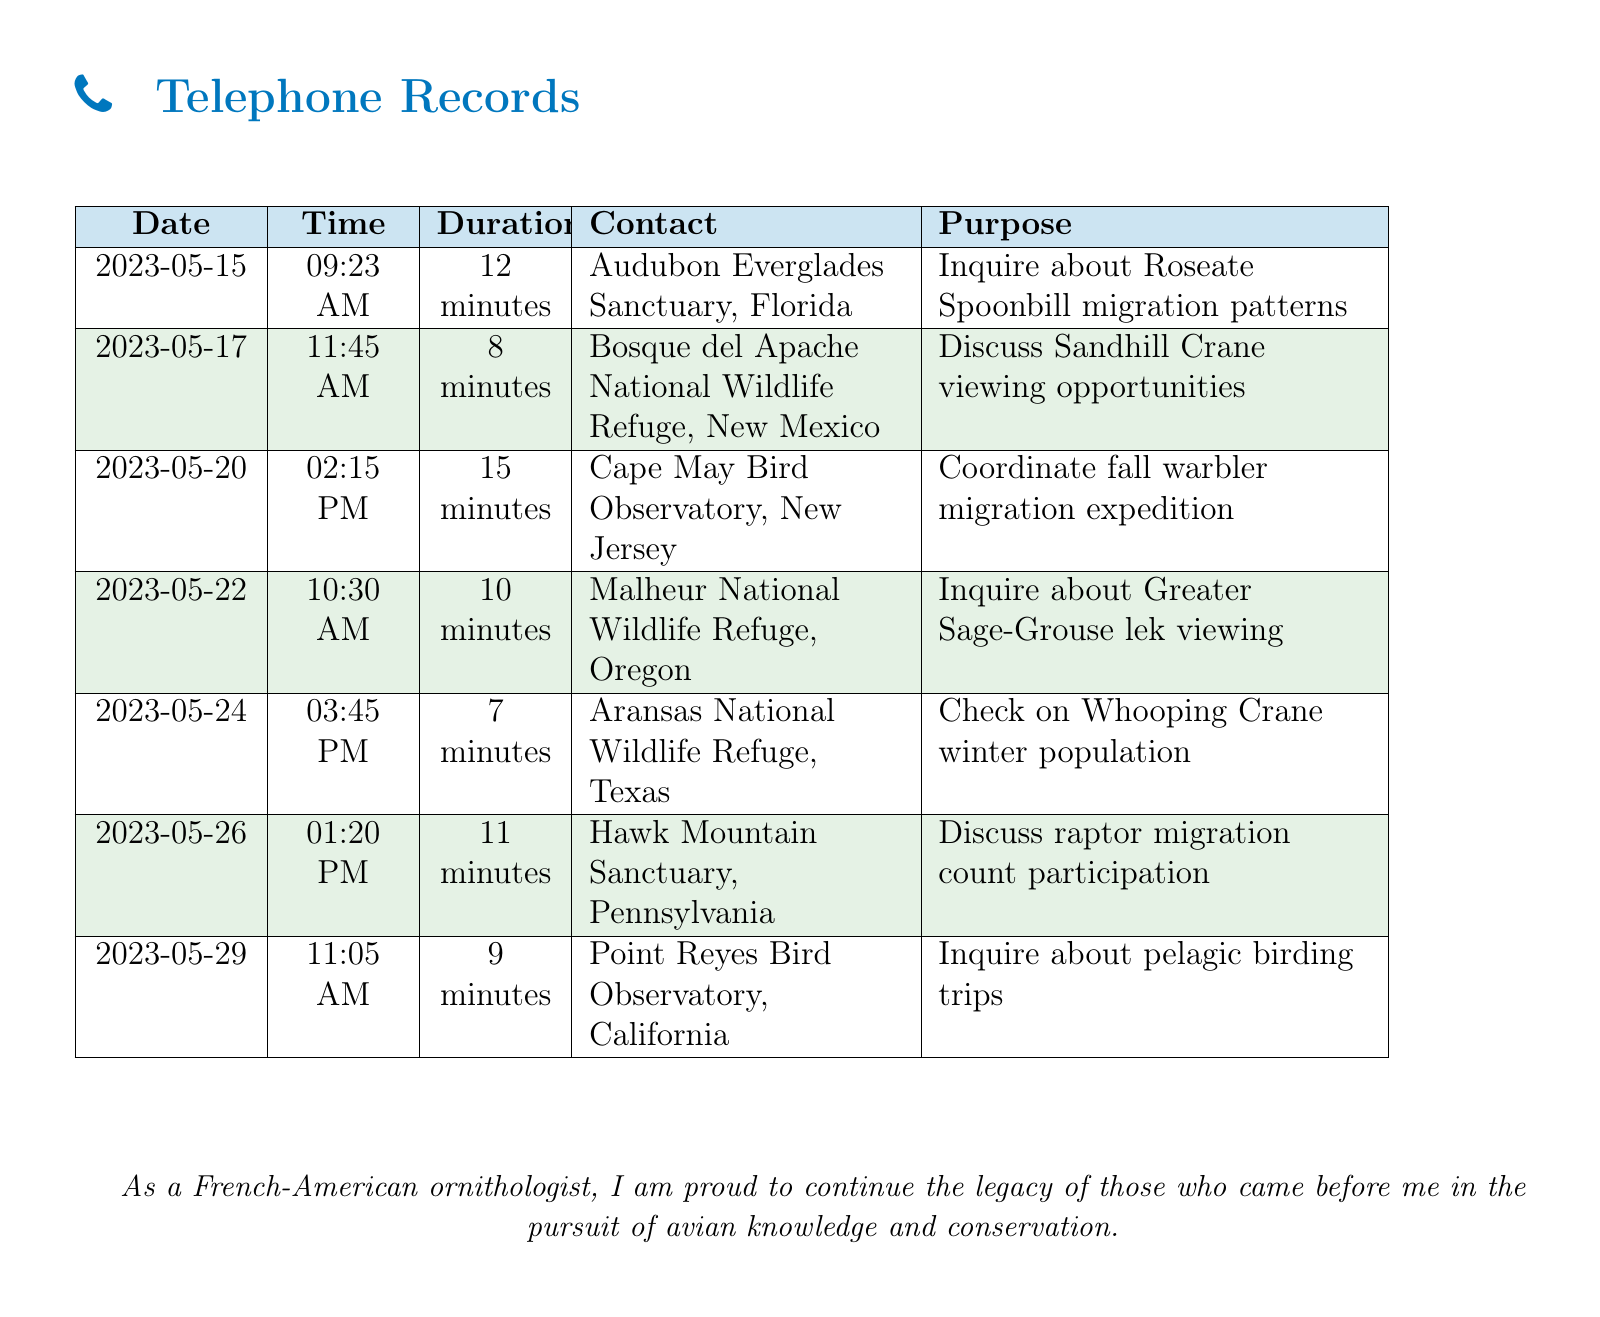What is the date of the call to the Audubon Everglades Sanctuary? The date is mentioned in the document under the date column for the specific call listed.
Answer: 2023-05-15 What was the main purpose of the call to the Cape May Bird Observatory? The purpose indicates the reason for the call listed alongside the contact name for that date.
Answer: Coordinate fall warbler migration expedition How long was the call to the Point Reyes Bird Observatory? The duration is specified for each call under the duration column in the table.
Answer: 9 minutes Which bird species was discussed in the call to Aransas National Wildlife Refuge? The document specifies the bird species in question within the purpose of that specific call.
Answer: Whooping Crane Which state is the Bosque del Apache National Wildlife Refuge located in? The document provides the state associated with each sanctuary next to its name in the contact column.
Answer: New Mexico How many minutes did the call to Hawk Mountain Sanctuary last? The duration of the call is given in the document under the duration column.
Answer: 11 minutes What is the total number of calls listed in the telephone records? The total number of individual calls can be counted from the table entries without any calculations.
Answer: 7 calls What was the main discussion topic for the call on May 22? The specific topic is stated in the purpose column for the corresponding date.
Answer: Inquire about Greater Sage-Grouse lek viewing 